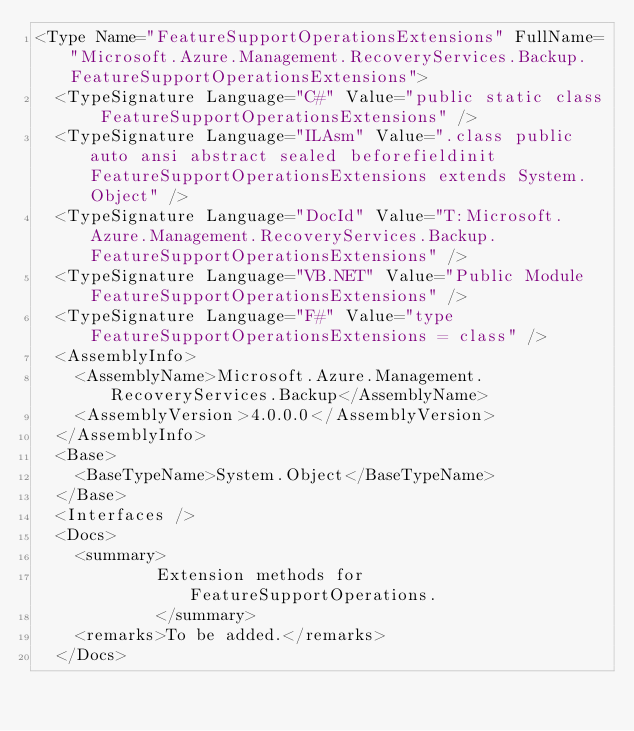<code> <loc_0><loc_0><loc_500><loc_500><_XML_><Type Name="FeatureSupportOperationsExtensions" FullName="Microsoft.Azure.Management.RecoveryServices.Backup.FeatureSupportOperationsExtensions">
  <TypeSignature Language="C#" Value="public static class FeatureSupportOperationsExtensions" />
  <TypeSignature Language="ILAsm" Value=".class public auto ansi abstract sealed beforefieldinit FeatureSupportOperationsExtensions extends System.Object" />
  <TypeSignature Language="DocId" Value="T:Microsoft.Azure.Management.RecoveryServices.Backup.FeatureSupportOperationsExtensions" />
  <TypeSignature Language="VB.NET" Value="Public Module FeatureSupportOperationsExtensions" />
  <TypeSignature Language="F#" Value="type FeatureSupportOperationsExtensions = class" />
  <AssemblyInfo>
    <AssemblyName>Microsoft.Azure.Management.RecoveryServices.Backup</AssemblyName>
    <AssemblyVersion>4.0.0.0</AssemblyVersion>
  </AssemblyInfo>
  <Base>
    <BaseTypeName>System.Object</BaseTypeName>
  </Base>
  <Interfaces />
  <Docs>
    <summary>
            Extension methods for FeatureSupportOperations.
            </summary>
    <remarks>To be added.</remarks>
  </Docs></code> 